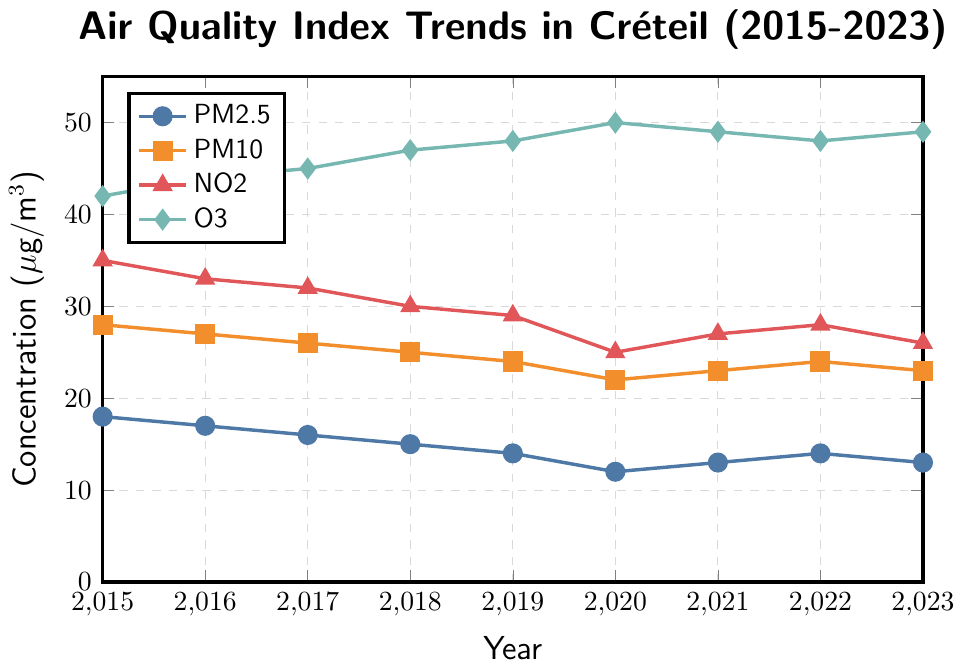What is the trend of PM2.5 from 2015 to 2023? To determine the trend of PM2.5, look at the data points from 2015 to 2023. PM2.5 decreases from 18 μg/m³ in 2015 to 12 μg/m³ in 2020 and then fluctuates around 13-14 μg/m³ until 2023.
Answer: Decreasing overall with minor fluctuations Which pollutant has shown the least variation in concentration over the years? To identify which pollutant has shown the least variation, examine the ranges of concentrations over the years. PM10 ranges from 22 to 28 μg/m³, while other pollutants show larger ranges.
Answer: PM10 In which year did the NO2 concentration reach its lowest point? Look for the lowest value in the NO2 data series from 2015 to 2023. The lowest value is 25 μg/m³ in 2020.
Answer: 2020 What is the highest recorded concentration of O3 between 2015 and 2023? Identify the maximum value in the O3 data series. The highest value is 50 μg/m³ in 2020.
Answer: 50 μg/m³ How much did the concentration of PM2.5 change from 2015 to 2020? Subtract the PM2.5 value in 2020 from the value in 2015. Difference = 18 - 12 = 6 μg/m³.
Answer: 6 μg/m³ Which year had the highest combined concentration of all pollutants? Sum the concentrations of each pollutant for each year and identify the highest sum. For example, 2015: 18+28+35+42 = 123 μg/m³, 2016: 17+27+33+44 = 121 μg/m³, and so on. The year with the highest sum is 2015 with 123 μg/m³.
Answer: 2015 Compare the trend of NO2 and O3 from 2015 to 2023 and state which one showed a more significant change. Evaluate the overall change for NO2 and O3 from 2015 to 2023. NO2 decreased from 35 to 26 μg/m³ (a reduction of 9), while O3 increased from 42 to 49 μg/m³ (an increase of 7). NO2 shows a more significant change.
Answer: NO2 In which two consecutive years did PM10 remain stable? Check where the PM10 values are equal in consecutive years. PM10 remained at 24 μg/m³ from 2021 to 2022.
Answer: 2021-2022 Is there any year where the concentration of PM2.5 and NO2 were the same? Compare PM2.5 and NO2 values for each year. There is no year in which PM2.5 and NO2 have the same concentration.
Answer: No What was the average concentration of O3 from 2015 to 2023? Sum the O3 values from 2015 to 2023 and divide by the number of years: (42 + 44 + 45 + 47 + 48 + 50 + 49 + 48 + 49) / 9 = 422 / 9 ≈ 46.89 μg/m³.
Answer: 46.89 μg/m³ 